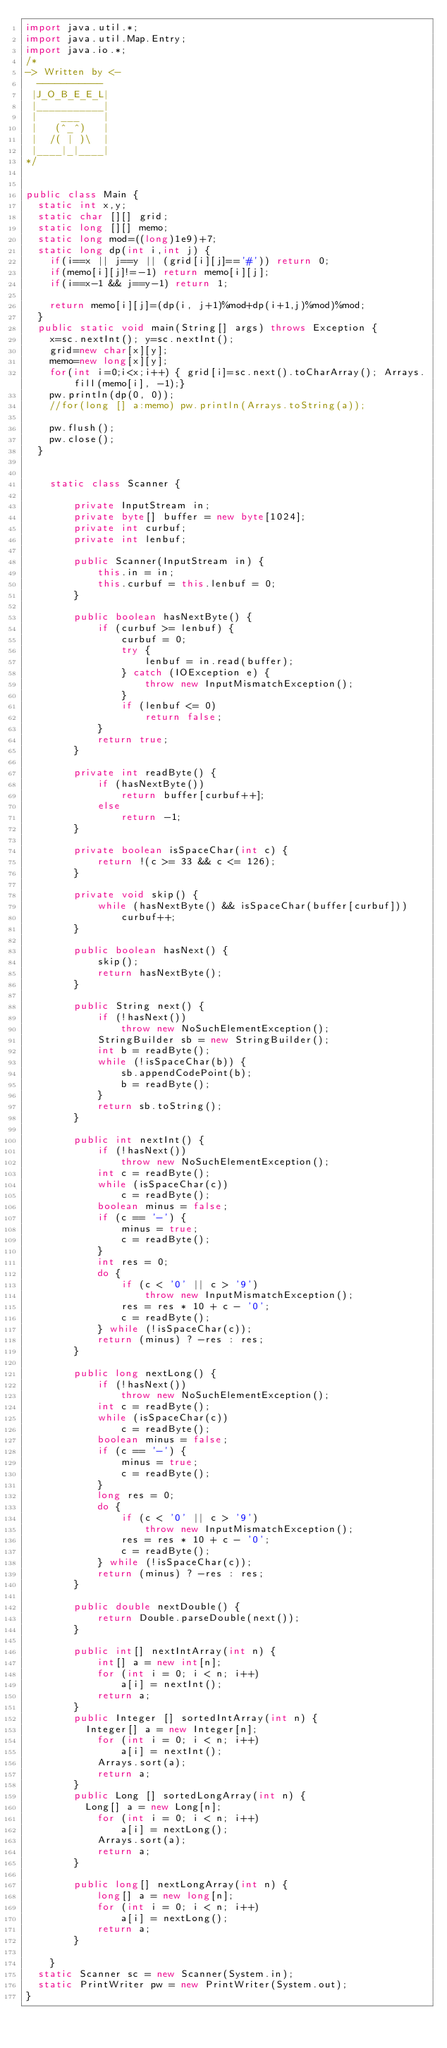Convert code to text. <code><loc_0><loc_0><loc_500><loc_500><_Java_>import java.util.*;
import java.util.Map.Entry;
import java.io.*;
/*
-> Written by <-
  -----------
 |J_O_B_E_E_L|
 |___________|
 |    ___    |
 |   (^_^)   |
 |  /( | )\  |
 |____|_|____|
*/


public class Main {
	static int x,y;
	static char [][] grid;
	static long [][] memo;
	static long mod=((long)1e9)+7;
	static long dp(int i,int j) {
		if(i==x || j==y || (grid[i][j]=='#')) return 0;
		if(memo[i][j]!=-1) return memo[i][j];
		if(i==x-1 && j==y-1) return 1;
		
		return memo[i][j]=(dp(i, j+1)%mod+dp(i+1,j)%mod)%mod;
	}
	public static void main(String[] args) throws Exception {
		x=sc.nextInt(); y=sc.nextInt();
		grid=new char[x][y];
		memo=new long[x][y];
		for(int i=0;i<x;i++) { grid[i]=sc.next().toCharArray(); Arrays.fill(memo[i], -1);}
		pw.println(dp(0, 0));
		//for(long [] a:memo) pw.println(Arrays.toString(a));

		pw.flush();
		pw.close();
	}
	
	
    static class Scanner {
    	 
        private InputStream in;
        private byte[] buffer = new byte[1024];
        private int curbuf;
        private int lenbuf;
 
        public Scanner(InputStream in) {
            this.in = in;
            this.curbuf = this.lenbuf = 0;
        }
 
        public boolean hasNextByte() {
            if (curbuf >= lenbuf) {
                curbuf = 0;
                try {
                    lenbuf = in.read(buffer);
                } catch (IOException e) {
                    throw new InputMismatchException();
                }
                if (lenbuf <= 0)
                    return false;
            }
            return true;
        }
 
        private int readByte() {
            if (hasNextByte())
                return buffer[curbuf++];
            else
                return -1;
        }
 
        private boolean isSpaceChar(int c) {
            return !(c >= 33 && c <= 126);
        }
 
        private void skip() {
            while (hasNextByte() && isSpaceChar(buffer[curbuf]))
                curbuf++;
        }
 
        public boolean hasNext() {
            skip();
            return hasNextByte();
        }
 
        public String next() {
            if (!hasNext())
                throw new NoSuchElementException();
            StringBuilder sb = new StringBuilder();
            int b = readByte();
            while (!isSpaceChar(b)) {
                sb.appendCodePoint(b);
                b = readByte();
            }
            return sb.toString();
        }
 
        public int nextInt() {
            if (!hasNext())
                throw new NoSuchElementException();
            int c = readByte();
            while (isSpaceChar(c))
                c = readByte();
            boolean minus = false;
            if (c == '-') {
                minus = true;
                c = readByte();
            }
            int res = 0;
            do {
                if (c < '0' || c > '9')
                    throw new InputMismatchException();
                res = res * 10 + c - '0';
                c = readByte();
            } while (!isSpaceChar(c));
            return (minus) ? -res : res;
        }
 
        public long nextLong() {
            if (!hasNext())
                throw new NoSuchElementException();
            int c = readByte();
            while (isSpaceChar(c))
                c = readByte();
            boolean minus = false;
            if (c == '-') {
                minus = true;
                c = readByte();
            }
            long res = 0;
            do {
                if (c < '0' || c > '9')
                    throw new InputMismatchException();
                res = res * 10 + c - '0';
                c = readByte();
            } while (!isSpaceChar(c));
            return (minus) ? -res : res;
        }
 
        public double nextDouble() {
            return Double.parseDouble(next());
        }
 
        public int[] nextIntArray(int n) {
            int[] a = new int[n];
            for (int i = 0; i < n; i++)
                a[i] = nextInt();
            return a;
        }
        public Integer [] sortedIntArray(int n) {
        	Integer[] a = new Integer[n];
            for (int i = 0; i < n; i++)
                a[i] = nextInt();
            Arrays.sort(a);
            return a;
        }
        public Long [] sortedLongArray(int n) {
        	Long[] a = new Long[n];
            for (int i = 0; i < n; i++)
                a[i] = nextLong();
            Arrays.sort(a);
            return a;
        }

        public long[] nextLongArray(int n) {
            long[] a = new long[n];
            for (int i = 0; i < n; i++)
                a[i] = nextLong();
            return a;
        }
 
    }
	static Scanner sc = new Scanner(System.in);
	static PrintWriter pw = new PrintWriter(System.out);
}
</code> 